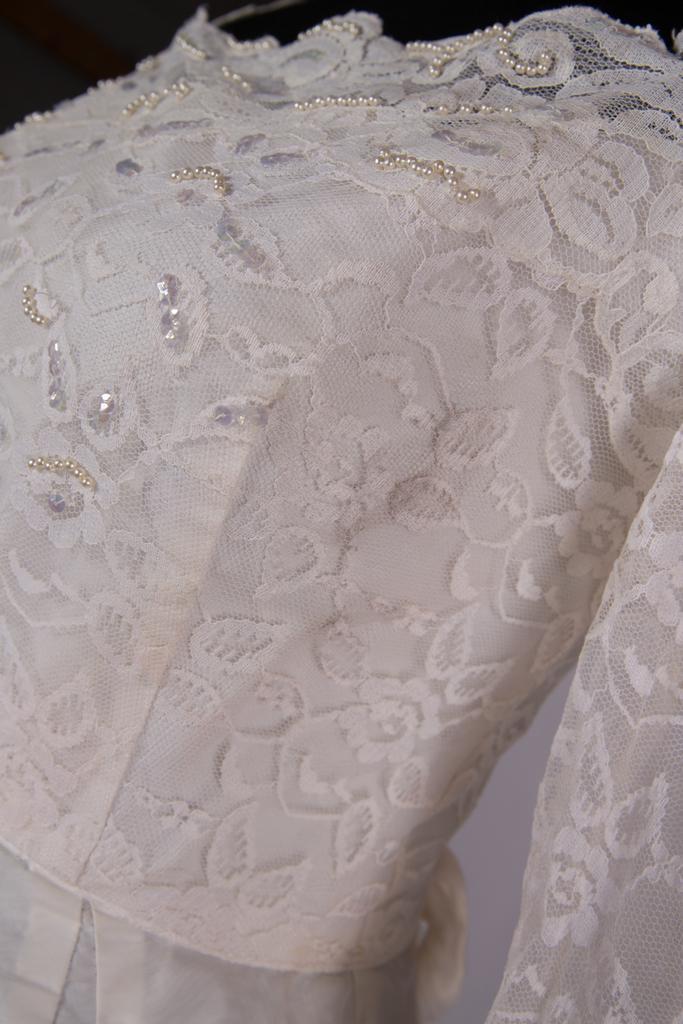In one or two sentences, can you explain what this image depicts? In this image I can see a white colour dress. 